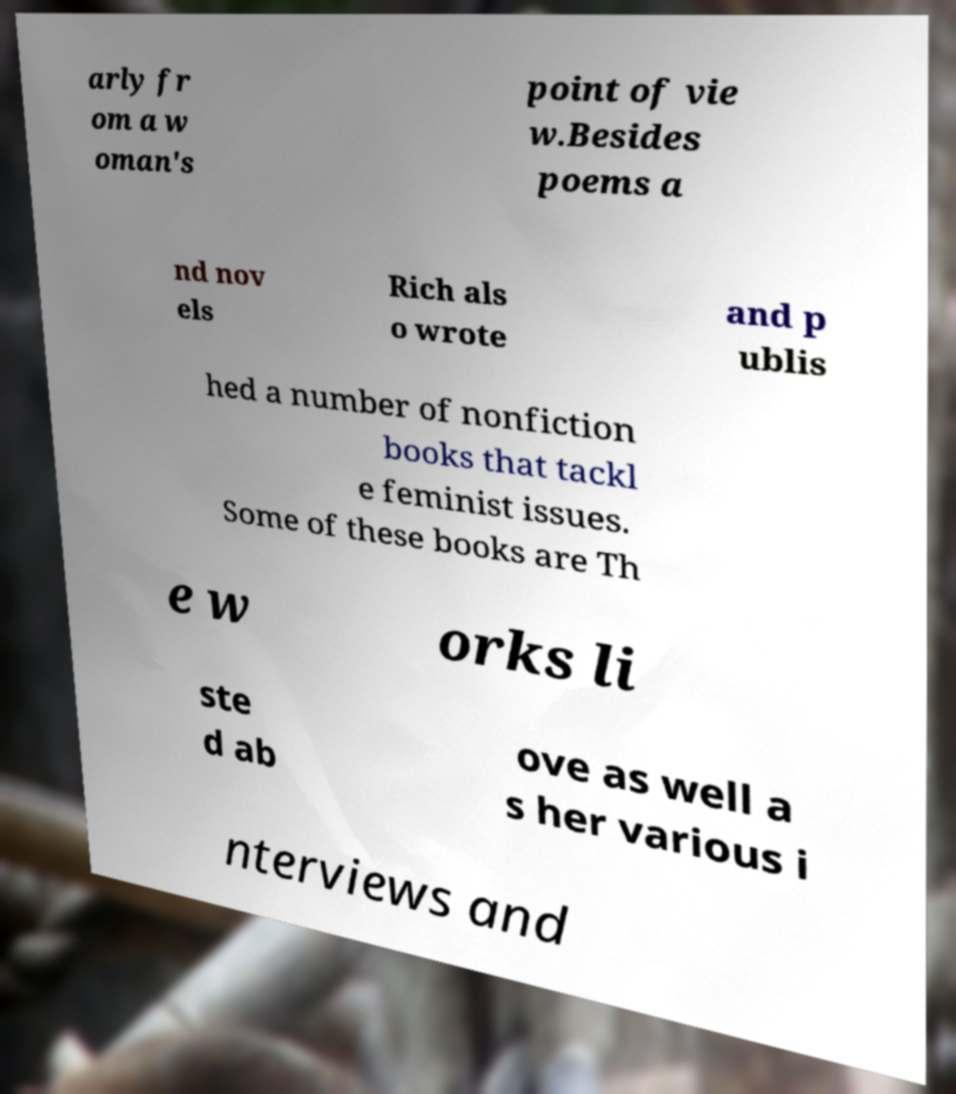I need the written content from this picture converted into text. Can you do that? arly fr om a w oman's point of vie w.Besides poems a nd nov els Rich als o wrote and p ublis hed a number of nonfiction books that tackl e feminist issues. Some of these books are Th e w orks li ste d ab ove as well a s her various i nterviews and 